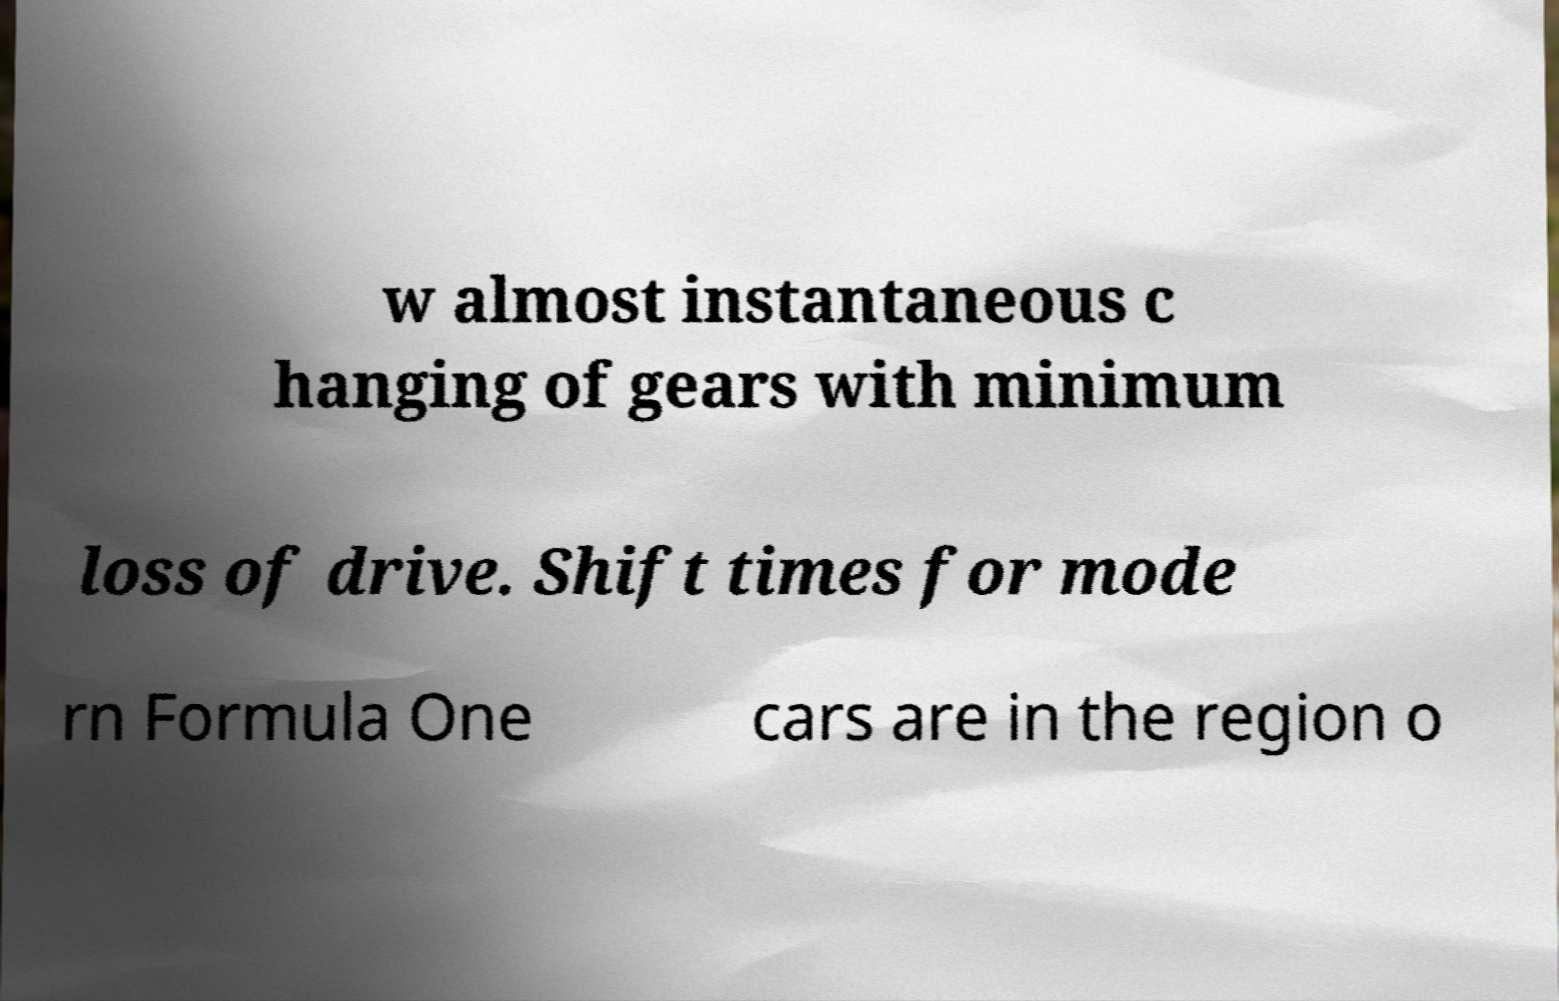Please identify and transcribe the text found in this image. w almost instantaneous c hanging of gears with minimum loss of drive. Shift times for mode rn Formula One cars are in the region o 